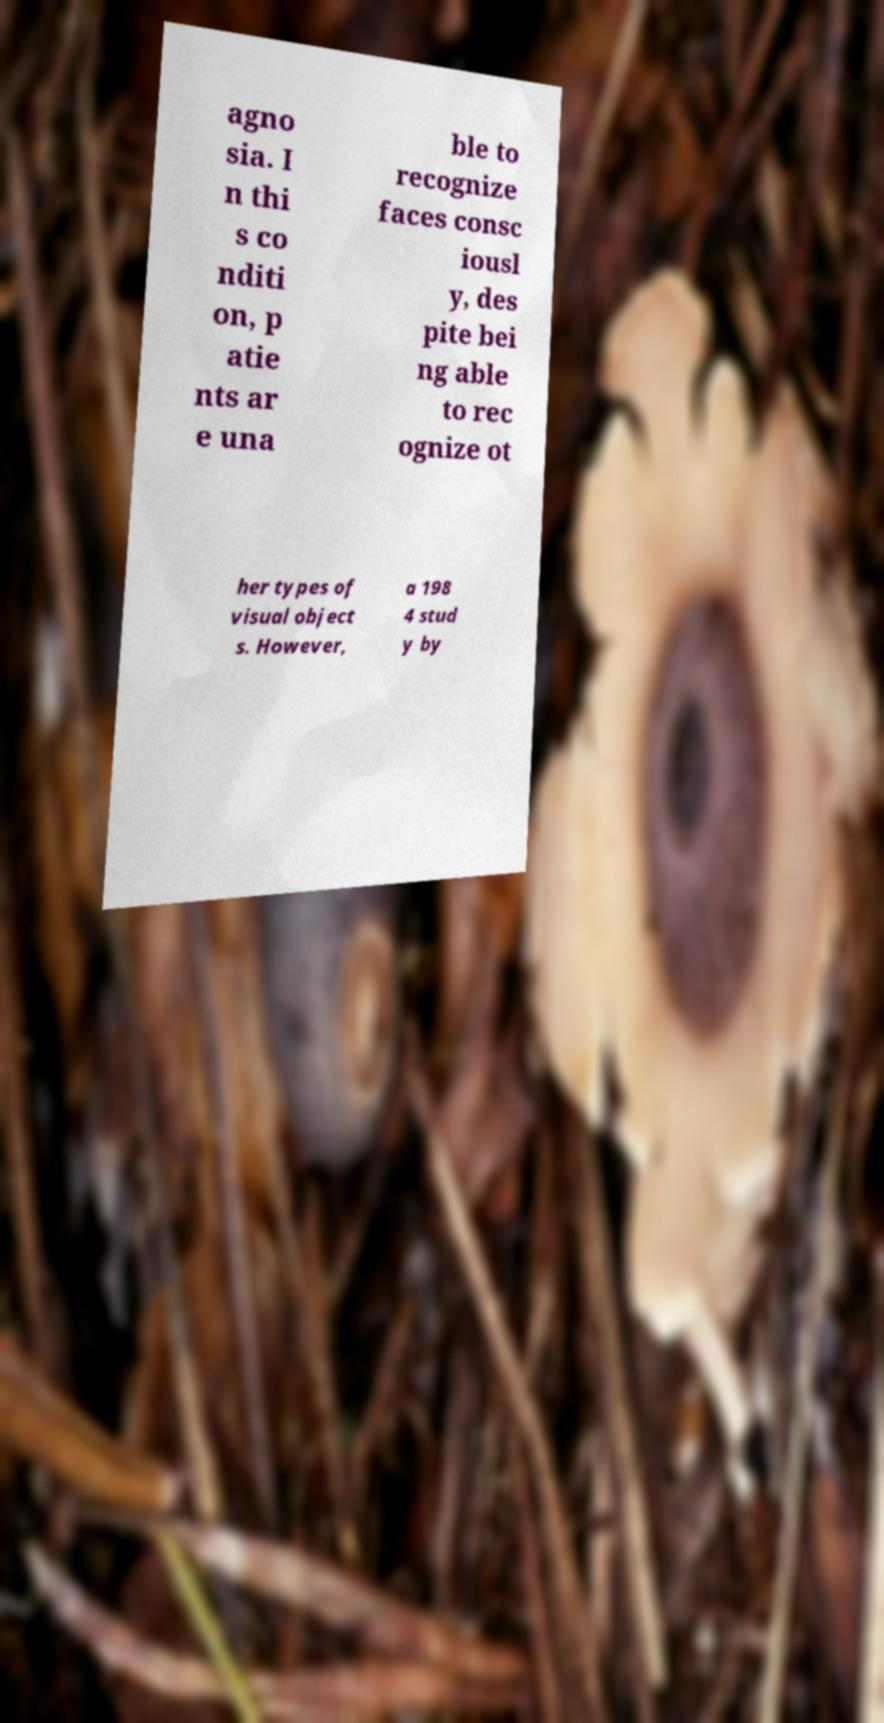Please identify and transcribe the text found in this image. agno sia. I n thi s co nditi on, p atie nts ar e una ble to recognize faces consc iousl y, des pite bei ng able to rec ognize ot her types of visual object s. However, a 198 4 stud y by 